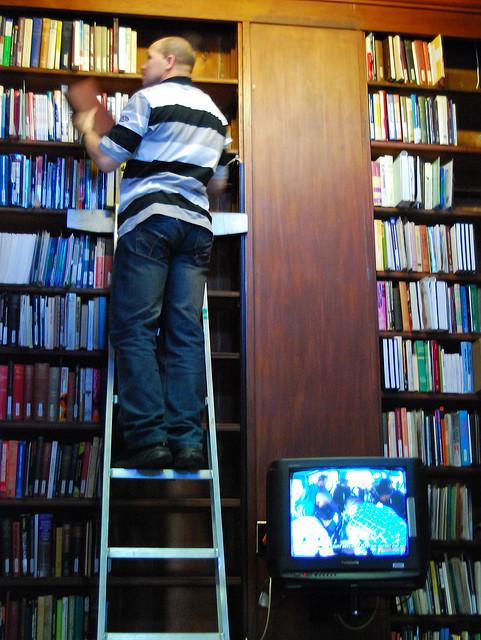What is the man on the ladder doing?
Give a very brief answer. Getting book. Is the man on the ladder?
Short answer required. Yes. Is the tv on?
Short answer required. Yes. 